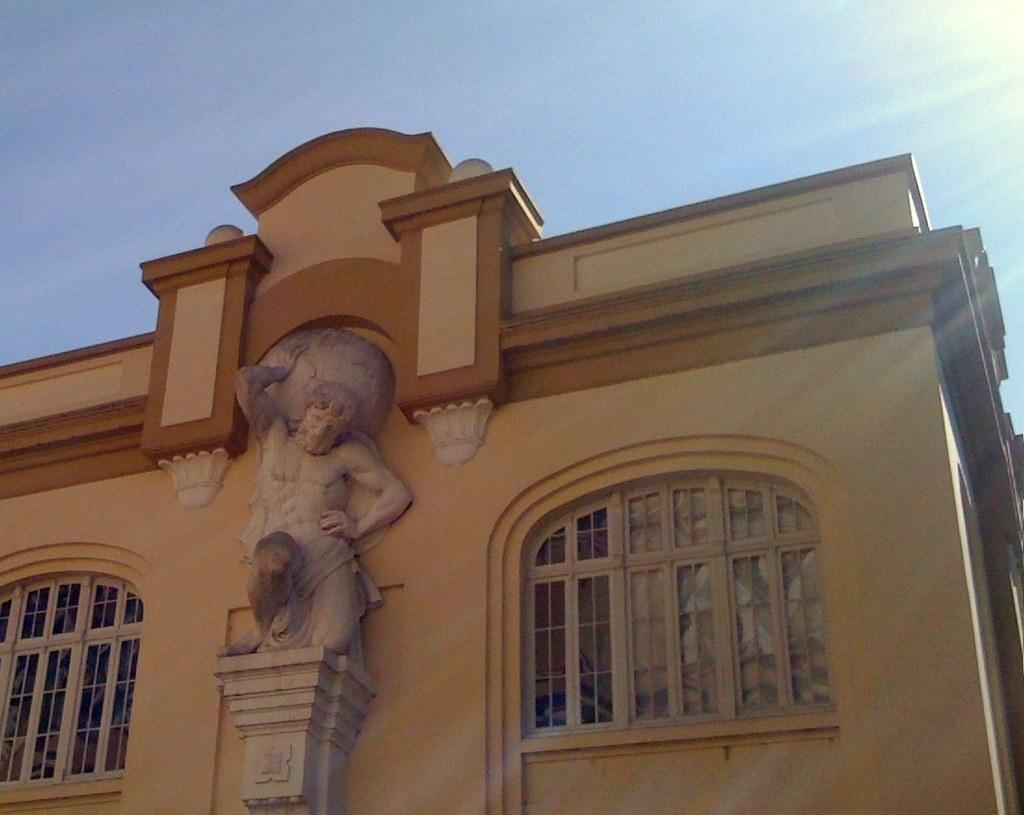What is the main subject of the image? There is a sculpture in the image. What architectural features can be seen in the image? There are windows and a building visible in the image. What is visible in the background of the image? The sky is visible in the background of the image. What type of square can be seen bursting into the image? There is no square or bursting action present in the image; it features a sculpture, windows, a building, and the sky. 